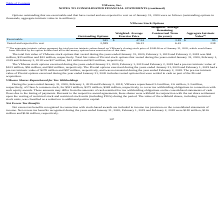According to Vmware's financial document, What did the aggregate intrinsic value represent? the total pre-tax intrinsic values based on VMware's closing stock price of $148.06 as of January 31, 2020, which would have been received by the option holders had all in-the-money options been exercised as of that date.. The document states: "(1) The aggregate intrinsic values represent the total pre-tax intrinsic values based on VMware's closing stock price of $148.06 as of January 31, 202..." Also, What was the amount of exercisable outstanding options? According to the financial document, 945 (in thousands). The relevant text states: "Exercisable 945 $ 47.24 3.81 $ 95..." Also, What was the aggregate intrinsic value that was vested and expected to vest? According to the financial document, 238 (in millions). The relevant text states: "Vested and expected to vest 2,589 56.13 6.41 238..." Also, can you calculate: What was the difference between outstanding options that were exercisable and vested and expected to vest? Based on the calculation: 2,589-945, the result is 1644 (in thousands). This is based on the information: "Vested and expected to vest 2,589 56.13 6.41 238 Exercisable 945 $ 47.24 3.81 $ 95..." The key data points involved are: 2,589, 945. Additionally, Which types of options had an exercise price that exceeded $50.00? Vested and expected to vest. The document states: "Vested and expected to vest 2,589 56.13 6.41 238..." Also, can you calculate: What was the difference between the aggregate intrinsic value between exercisable and vested and expected to vest options?  Based on the calculation: 238-95, the result is 143 (in millions). This is based on the information: "Exercisable 945 $ 47.24 3.81 $ 95 Vested and expected to vest 2,589 56.13 6.41 238..." The key data points involved are: 238, 95. 